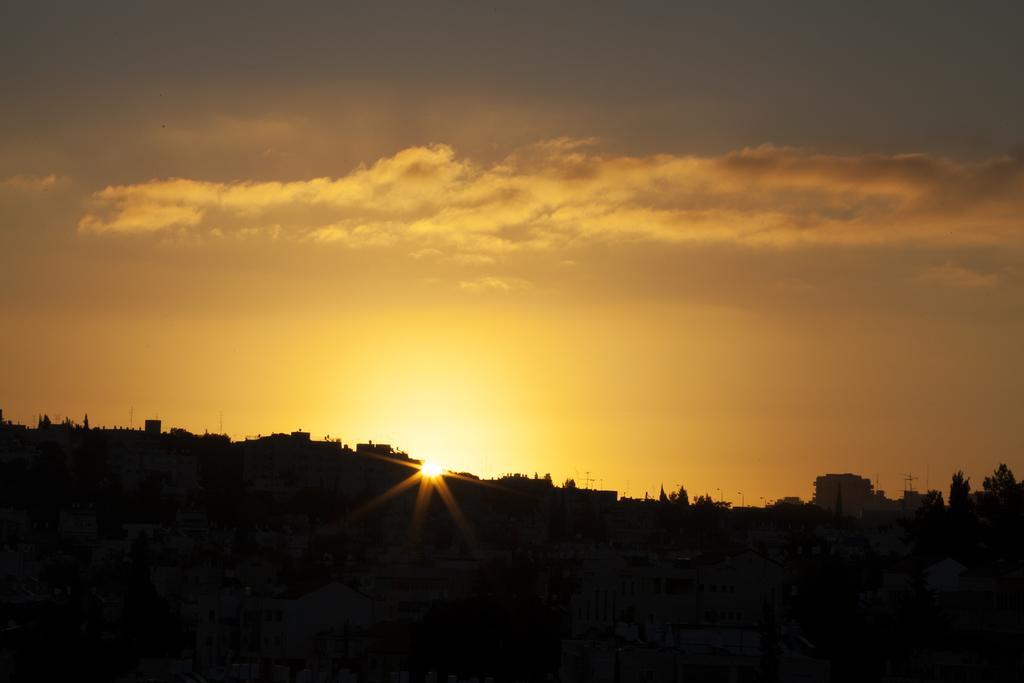Can you describe this image briefly? In the picture we can see many houses, buildings, trees and in the dark and behind it, we can see the sunset in the sky with clouds. 